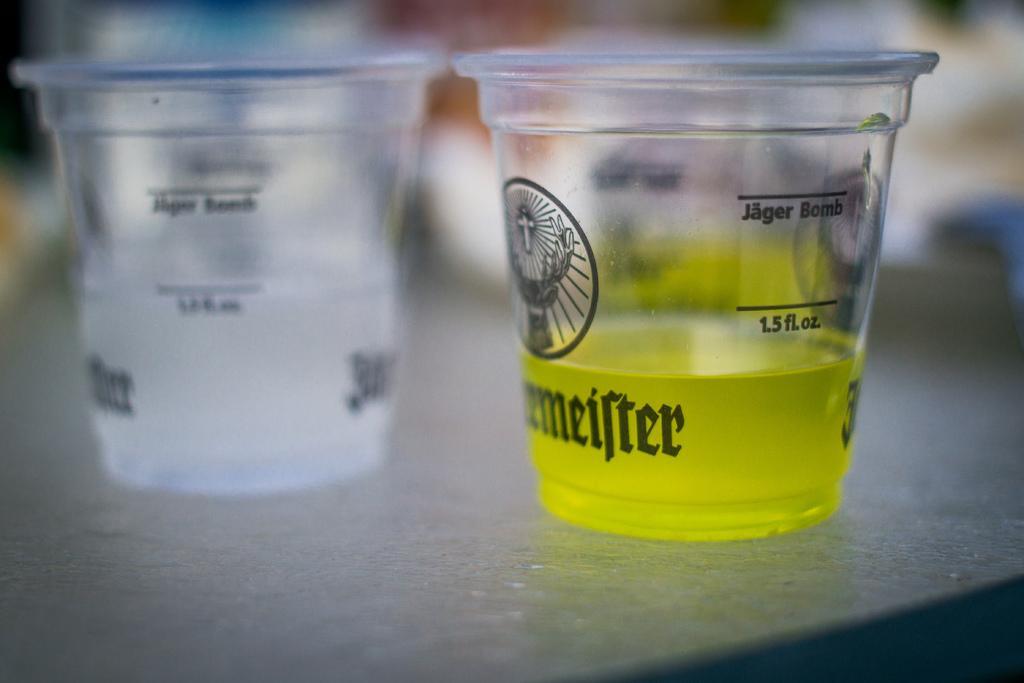Please provide a concise description of this image. In the image we can see two glasses and there is a liquid in the glass, this is a surface and the background is blurred. 